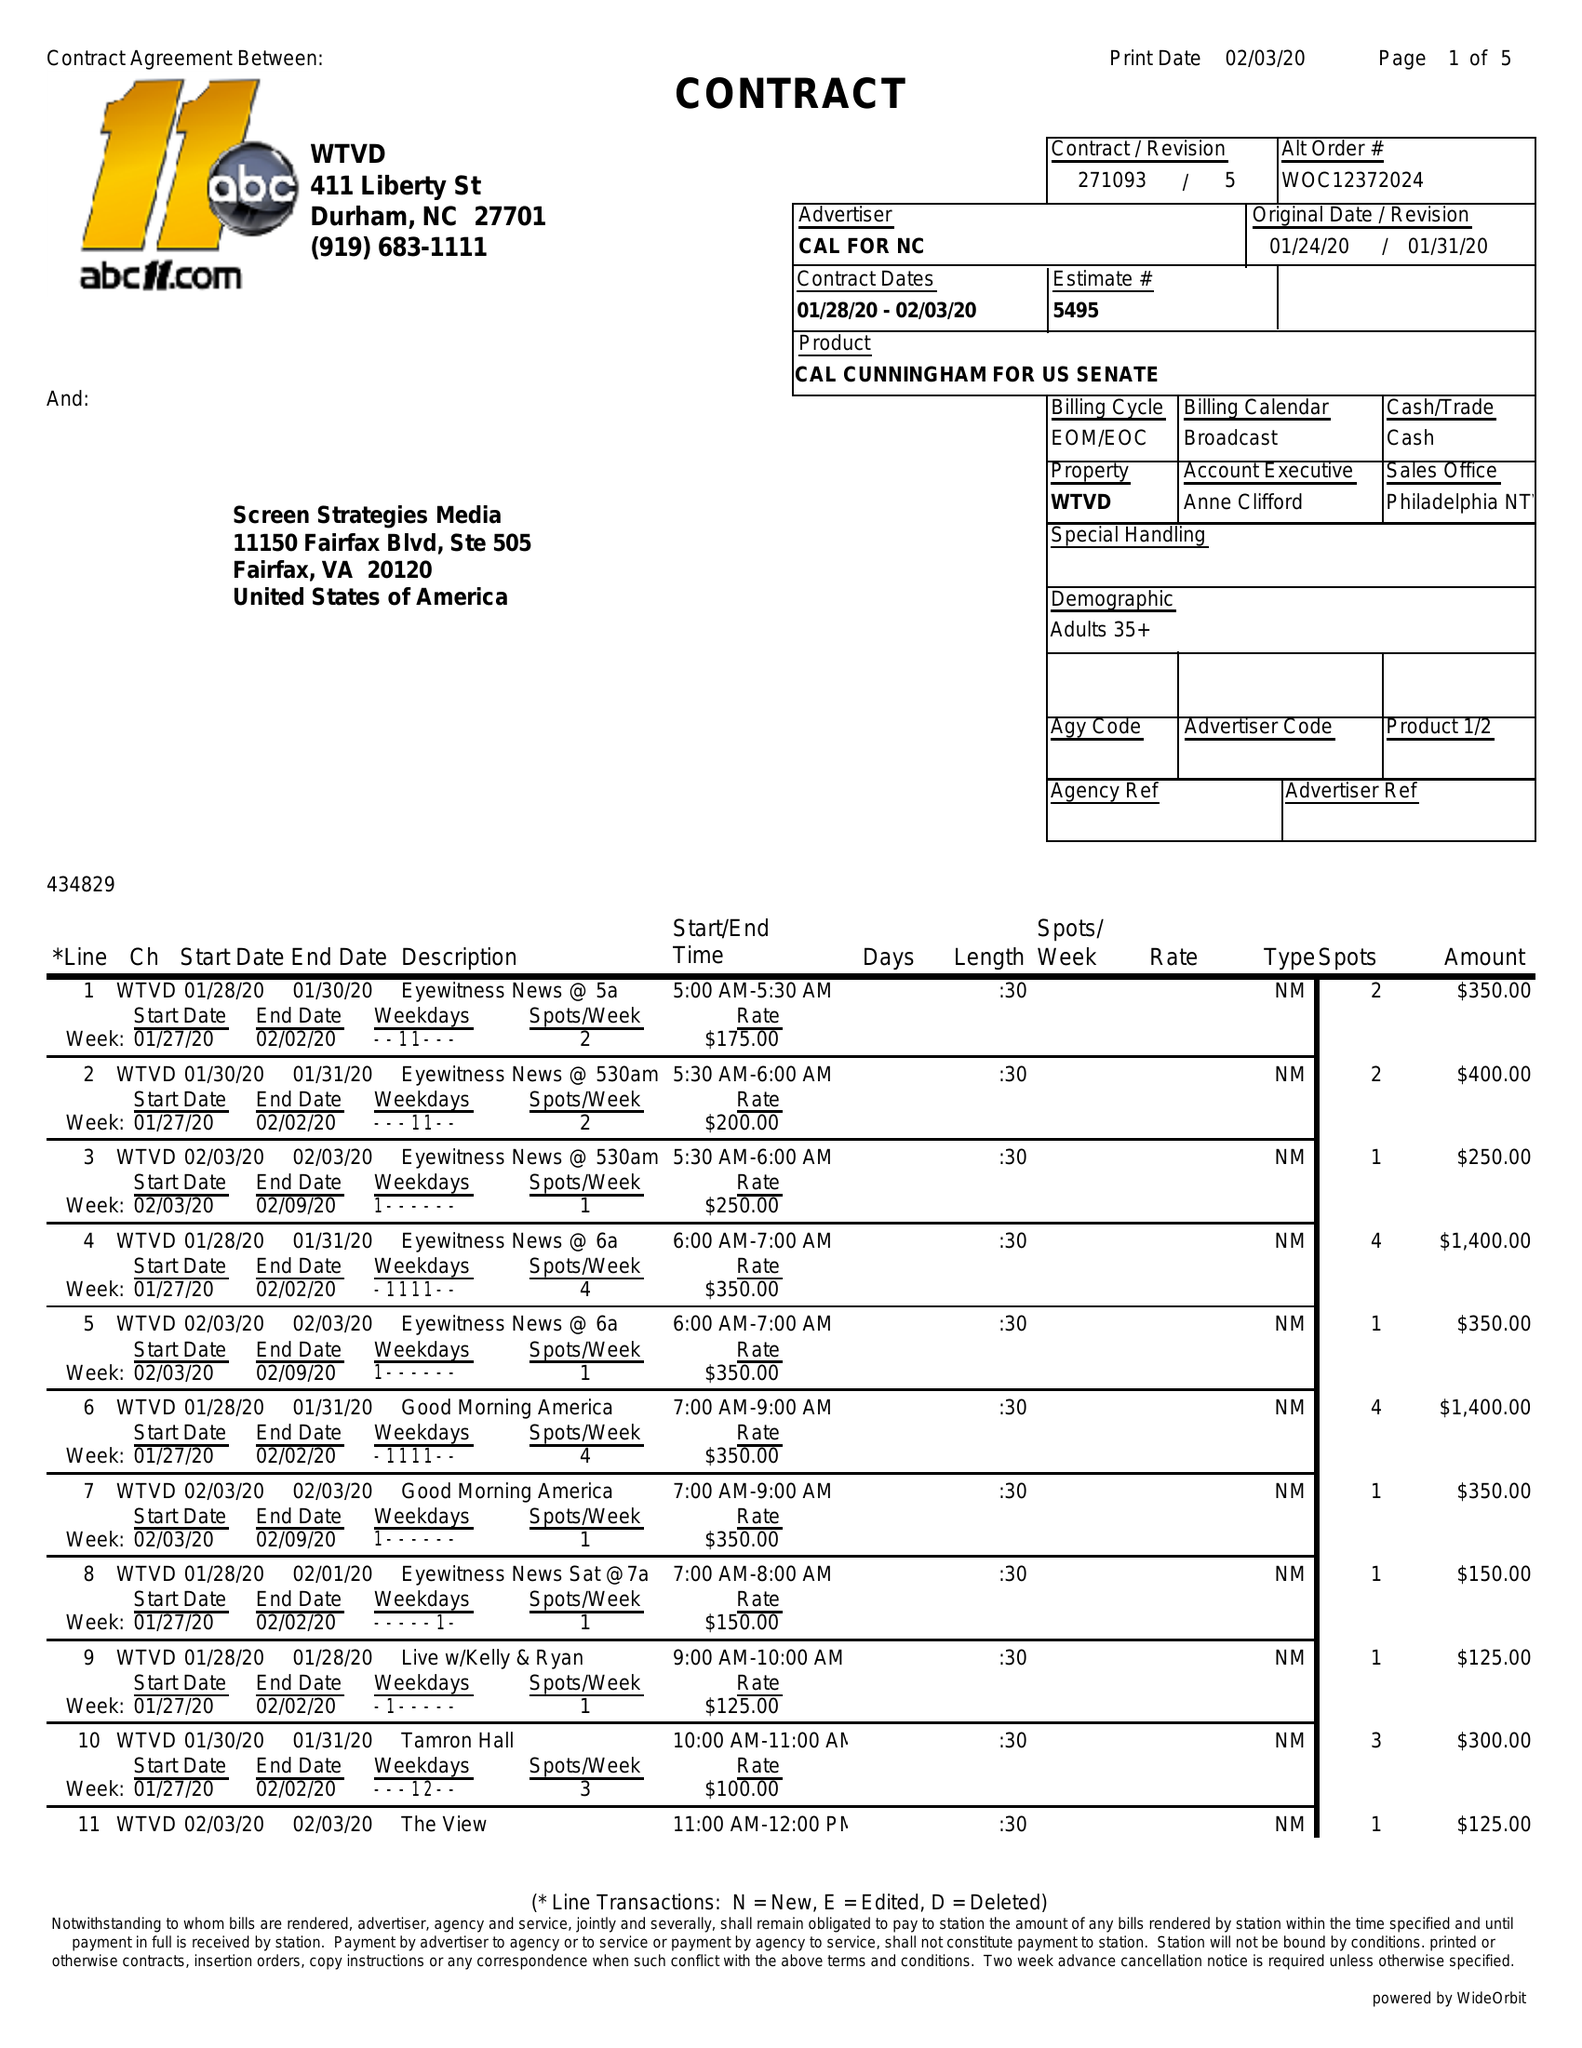What is the value for the advertiser?
Answer the question using a single word or phrase. CAL FOR NC 